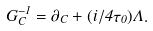<formula> <loc_0><loc_0><loc_500><loc_500>G _ { C } ^ { - 1 } = \partial _ { C } + ( i / 4 \tau _ { 0 } ) \Lambda .</formula> 